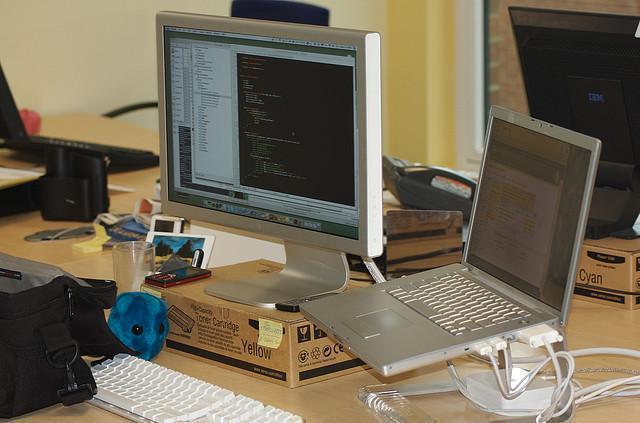How many computers do you see?
Give a very brief answer. 2. How many laptops are in the picture?
Give a very brief answer. 1. How many keyboards can be seen?
Give a very brief answer. 2. 